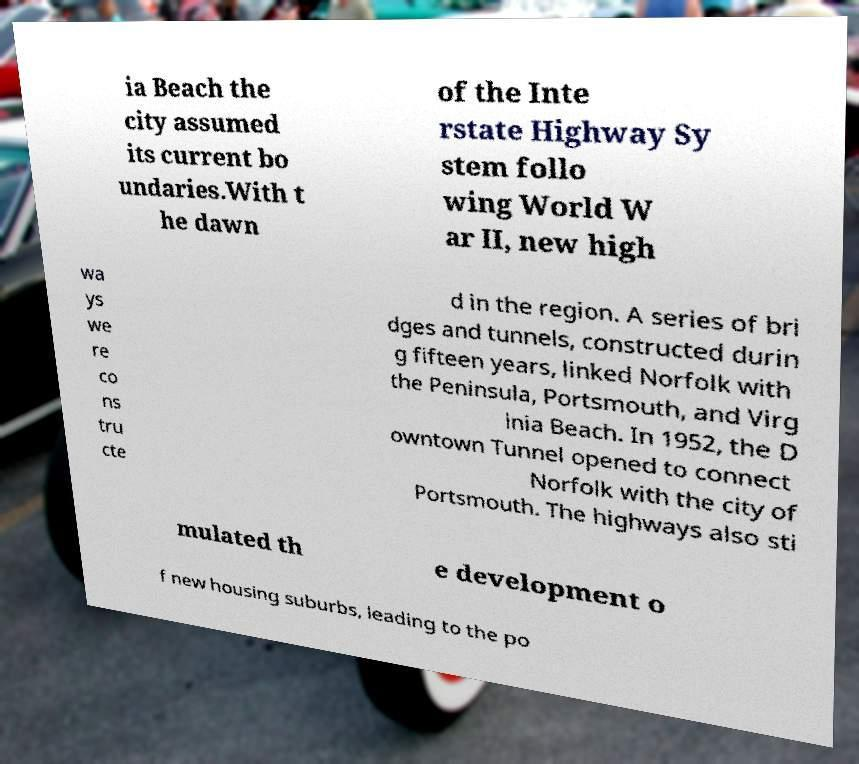Can you accurately transcribe the text from the provided image for me? ia Beach the city assumed its current bo undaries.With t he dawn of the Inte rstate Highway Sy stem follo wing World W ar II, new high wa ys we re co ns tru cte d in the region. A series of bri dges and tunnels, constructed durin g fifteen years, linked Norfolk with the Peninsula, Portsmouth, and Virg inia Beach. In 1952, the D owntown Tunnel opened to connect Norfolk with the city of Portsmouth. The highways also sti mulated th e development o f new housing suburbs, leading to the po 